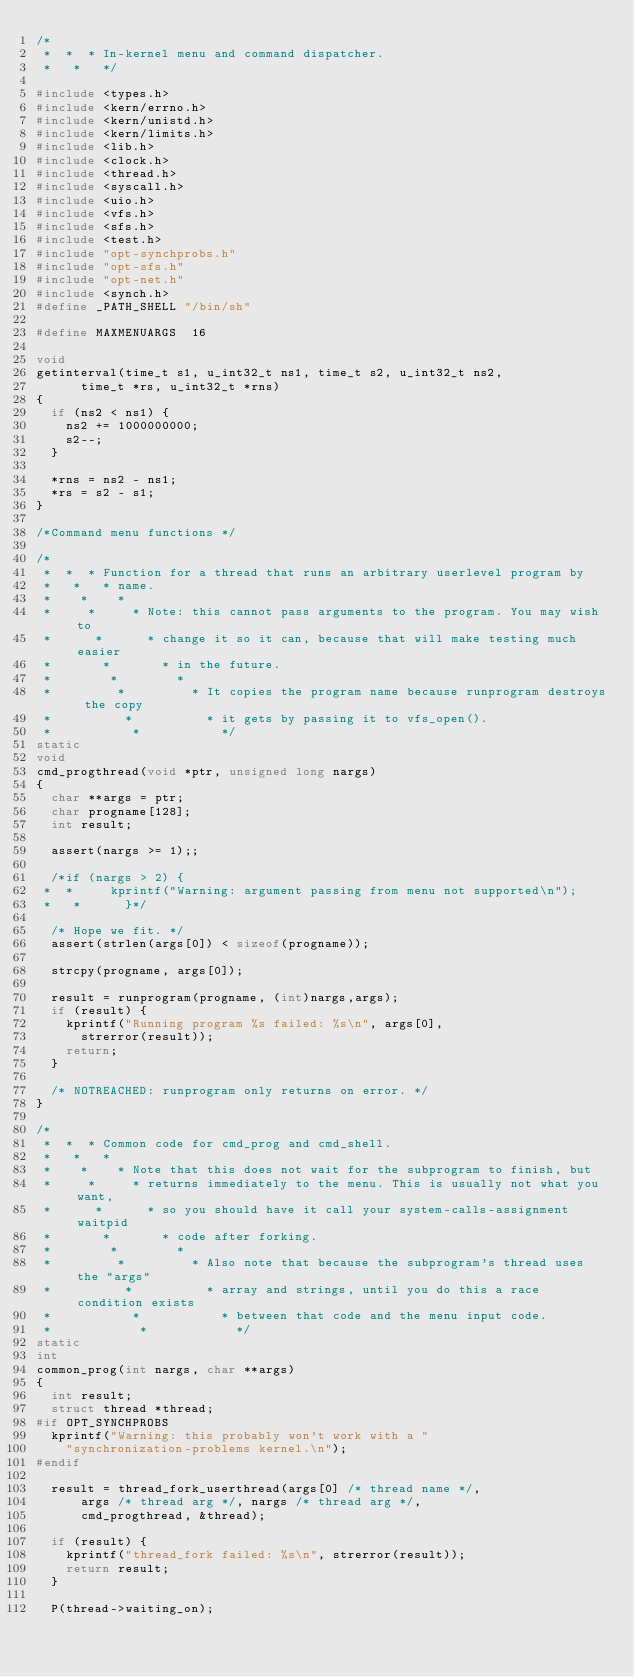<code> <loc_0><loc_0><loc_500><loc_500><_C_>/*
 *  *  * In-kernel menu and command dispatcher.
 *   *   */

#include <types.h>
#include <kern/errno.h>
#include <kern/unistd.h>
#include <kern/limits.h>
#include <lib.h>
#include <clock.h>
#include <thread.h>
#include <syscall.h>
#include <uio.h>
#include <vfs.h>
#include <sfs.h>
#include <test.h>
#include "opt-synchprobs.h"
#include "opt-sfs.h"
#include "opt-net.h"
#include <synch.h>
#define _PATH_SHELL "/bin/sh"

#define MAXMENUARGS  16

void
getinterval(time_t s1, u_int32_t ns1, time_t s2, u_int32_t ns2,
	    time_t *rs, u_int32_t *rns)
{
	if (ns2 < ns1) {
		ns2 += 1000000000;
		s2--;
	}

	*rns = ns2 - ns1;
	*rs = s2 - s1;
}

/*Command menu functions */

/*
 *  *  * Function for a thread that runs an arbitrary userlevel program by
 *   *   * name.
 *    *    *
 *     *     * Note: this cannot pass arguments to the program. You may wish to 
 *      *      * change it so it can, because that will make testing much easier
 *       *       * in the future.
 *        *        *
 *         *         * It copies the program name because runprogram destroys the copy
 *          *          * it gets by passing it to vfs_open(). 
 *           *           */
static
void
cmd_progthread(void *ptr, unsigned long nargs)
{
	char **args = ptr;
	char progname[128];
	int result;

	assert(nargs >= 1);;

	/*if (nargs > 2) {
 *  * 		kprintf("Warning: argument passing from menu not supported\n");
 *   * 			}*/

	/* Hope we fit. */
	assert(strlen(args[0]) < sizeof(progname));

	strcpy(progname, args[0]);

	result = runprogram(progname, (int)nargs,args);
	if (result) {
		kprintf("Running program %s failed: %s\n", args[0],
			strerror(result));
		return;
	}

	/* NOTREACHED: runprogram only returns on error. */
}

/*
 *  *  * Common code for cmd_prog and cmd_shell.
 *   *   *
 *    *    * Note that this does not wait for the subprogram to finish, but
 *     *     * returns immediately to the menu. This is usually not what you want,
 *      *      * so you should have it call your system-calls-assignment waitpid
 *       *       * code after forking.
 *        *        *
 *         *         * Also note that because the subprogram's thread uses the "args"
 *          *          * array and strings, until you do this a race condition exists
 *           *           * between that code and the menu input code.
 *            *            */
static
int
common_prog(int nargs, char **args)
{
	int result;
	struct thread *thread;
#if OPT_SYNCHPROBS
	kprintf("Warning: this probably won't work with a "
		"synchronization-problems kernel.\n");
#endif

	result = thread_fork_userthread(args[0] /* thread name */,
			args /* thread arg */, nargs /* thread arg */,
			cmd_progthread, &thread);

	if (result) {
		kprintf("thread_fork failed: %s\n", strerror(result));
		return result;
	}

	P(thread->waiting_on);
	</code> 